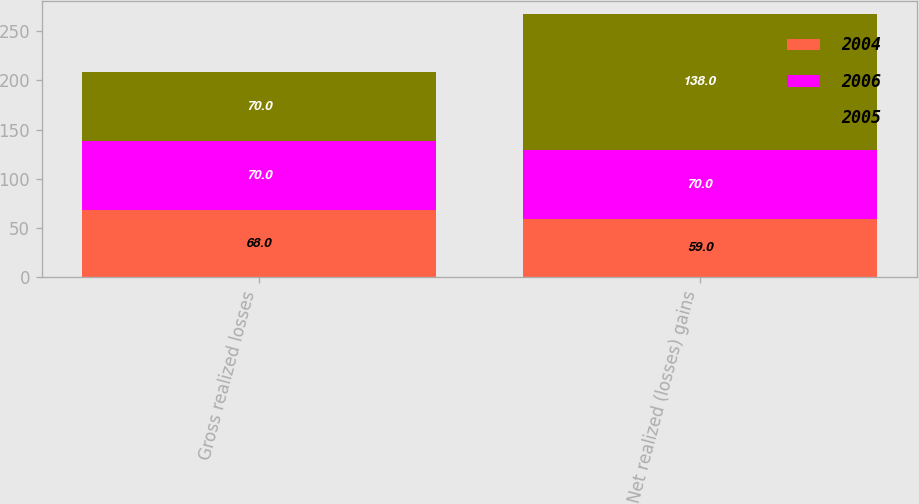Convert chart. <chart><loc_0><loc_0><loc_500><loc_500><stacked_bar_chart><ecel><fcel>Gross realized losses<fcel>Net realized (losses) gains<nl><fcel>2004<fcel>68<fcel>59<nl><fcel>2006<fcel>70<fcel>70<nl><fcel>2005<fcel>70<fcel>138<nl></chart> 